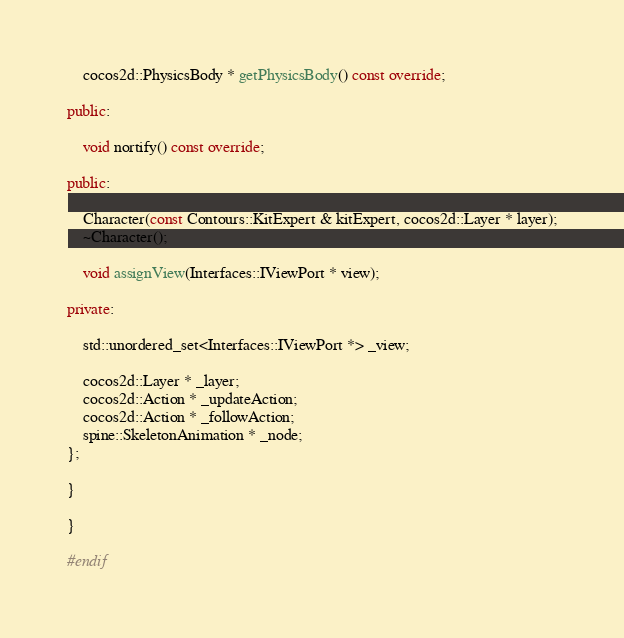<code> <loc_0><loc_0><loc_500><loc_500><_C++_>	cocos2d::PhysicsBody * getPhysicsBody() const override;

public:

	void nortify() const override;

public:

	Character(const Contours::KitExpert & kitExpert, cocos2d::Layer * layer);
	~Character();

	void assignView(Interfaces::IViewPort * view);

private:

	std::unordered_set<Interfaces::IViewPort *> _view;

	cocos2d::Layer * _layer;
	cocos2d::Action * _updateAction;
	cocos2d::Action * _followAction;
	spine::SkeletonAnimation * _node;
};

}

}

#endif</code> 